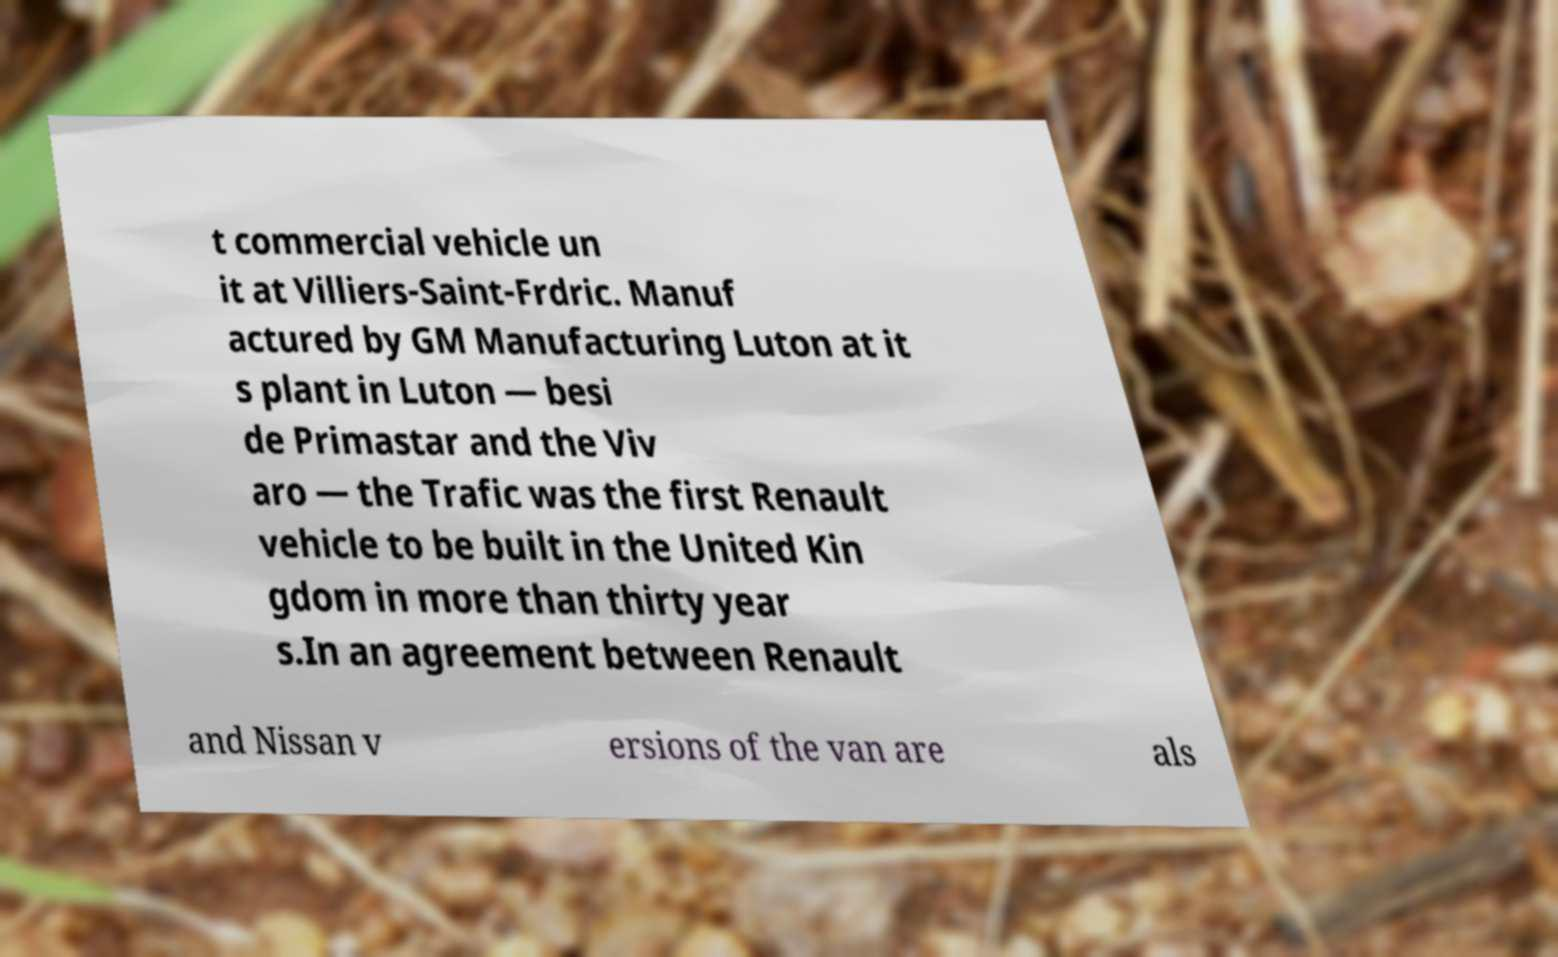Could you extract and type out the text from this image? t commercial vehicle un it at Villiers-Saint-Frdric. Manuf actured by GM Manufacturing Luton at it s plant in Luton — besi de Primastar and the Viv aro — the Trafic was the first Renault vehicle to be built in the United Kin gdom in more than thirty year s.In an agreement between Renault and Nissan v ersions of the van are als 